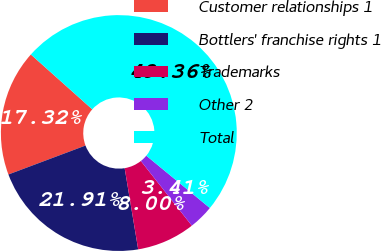Convert chart. <chart><loc_0><loc_0><loc_500><loc_500><pie_chart><fcel>Customer relationships 1<fcel>Bottlers' franchise rights 1<fcel>Trademarks<fcel>Other 2<fcel>Total<nl><fcel>17.32%<fcel>21.91%<fcel>8.0%<fcel>3.41%<fcel>49.36%<nl></chart> 